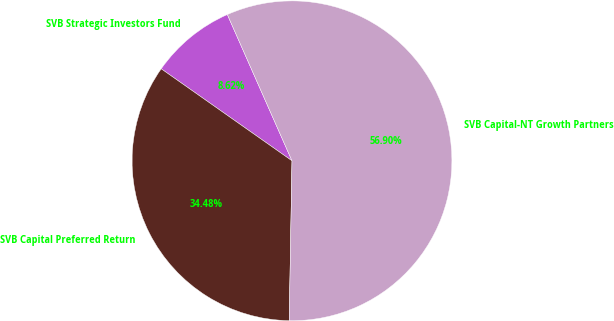Convert chart to OTSL. <chart><loc_0><loc_0><loc_500><loc_500><pie_chart><fcel>SVB Strategic Investors Fund<fcel>SVB Capital Preferred Return<fcel>SVB Capital-NT Growth Partners<nl><fcel>8.62%<fcel>34.48%<fcel>56.9%<nl></chart> 